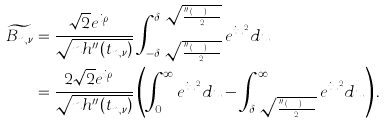<formula> <loc_0><loc_0><loc_500><loc_500>\widetilde { B _ { n , \nu } } & = \frac { \sqrt { 2 } e ^ { i \rho _ { n , \nu } } } { \sqrt { n h ^ { \prime \prime } ( t _ { n , \nu } ) } } \int _ { - \delta _ { n } \sqrt { \frac { n h ^ { \prime \prime } ( t _ { n , \nu } ) } { 2 } } } ^ { \delta _ { n } \sqrt { \frac { n h ^ { \prime \prime } ( t _ { n , \nu } ) } { 2 } } } e ^ { i u ^ { 2 } } d u \\ & = \frac { 2 \sqrt { 2 } e ^ { i \rho _ { n , \nu } } } { \sqrt { n h ^ { \prime \prime } ( t _ { n , \nu } ) } } \left ( \int _ { 0 } ^ { \infty } e ^ { i u ^ { 2 } } d u - \int _ { \delta _ { n } \sqrt { \frac { n h ^ { \prime \prime } ( t _ { n , \nu } ) } { 2 } } } ^ { \infty } e ^ { i u ^ { 2 } } d u \right ) .</formula> 